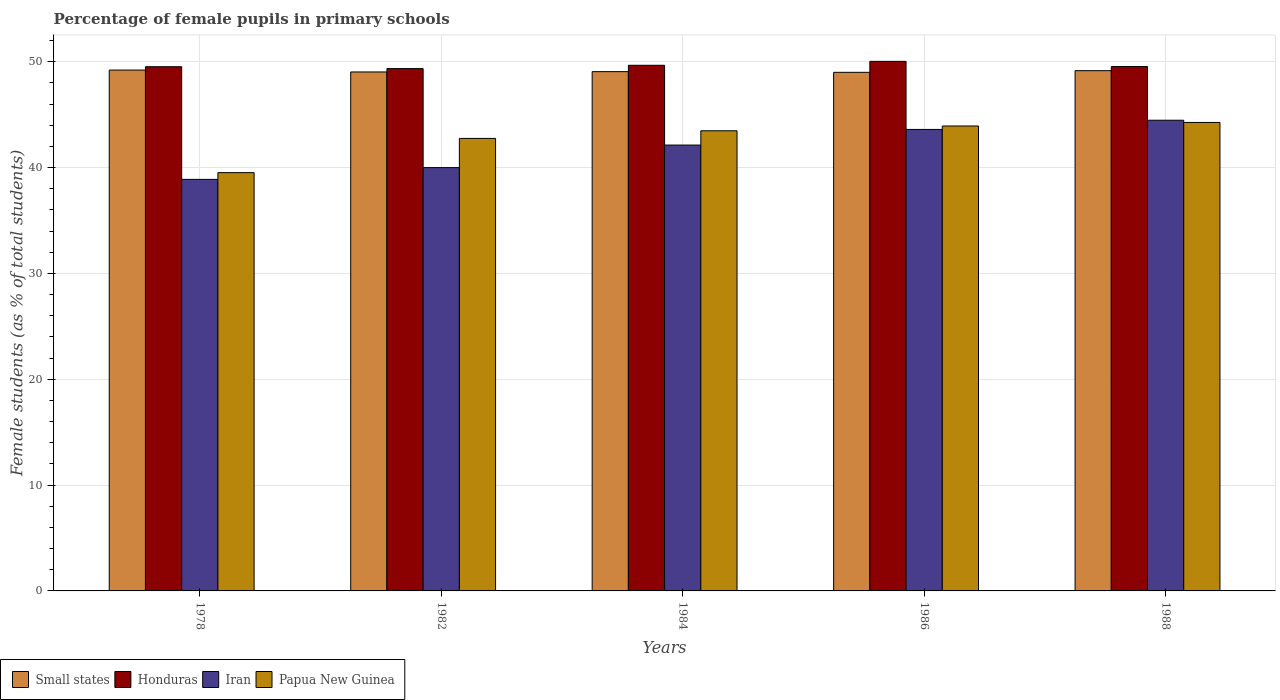How many different coloured bars are there?
Keep it short and to the point. 4. How many groups of bars are there?
Your response must be concise. 5. How many bars are there on the 4th tick from the left?
Your response must be concise. 4. In how many cases, is the number of bars for a given year not equal to the number of legend labels?
Make the answer very short. 0. What is the percentage of female pupils in primary schools in Iran in 1978?
Offer a very short reply. 38.89. Across all years, what is the maximum percentage of female pupils in primary schools in Honduras?
Offer a very short reply. 50.04. Across all years, what is the minimum percentage of female pupils in primary schools in Iran?
Keep it short and to the point. 38.89. In which year was the percentage of female pupils in primary schools in Iran maximum?
Ensure brevity in your answer.  1988. What is the total percentage of female pupils in primary schools in Papua New Guinea in the graph?
Your answer should be compact. 213.96. What is the difference between the percentage of female pupils in primary schools in Iran in 1982 and that in 1986?
Ensure brevity in your answer.  -3.61. What is the difference between the percentage of female pupils in primary schools in Papua New Guinea in 1988 and the percentage of female pupils in primary schools in Small states in 1982?
Ensure brevity in your answer.  -4.77. What is the average percentage of female pupils in primary schools in Iran per year?
Ensure brevity in your answer.  41.82. In the year 1984, what is the difference between the percentage of female pupils in primary schools in Papua New Guinea and percentage of female pupils in primary schools in Honduras?
Ensure brevity in your answer.  -6.19. In how many years, is the percentage of female pupils in primary schools in Honduras greater than 14 %?
Offer a very short reply. 5. What is the ratio of the percentage of female pupils in primary schools in Iran in 1978 to that in 1982?
Give a very brief answer. 0.97. Is the difference between the percentage of female pupils in primary schools in Papua New Guinea in 1984 and 1988 greater than the difference between the percentage of female pupils in primary schools in Honduras in 1984 and 1988?
Offer a very short reply. No. What is the difference between the highest and the second highest percentage of female pupils in primary schools in Honduras?
Offer a terse response. 0.37. What is the difference between the highest and the lowest percentage of female pupils in primary schools in Iran?
Your response must be concise. 5.59. In how many years, is the percentage of female pupils in primary schools in Honduras greater than the average percentage of female pupils in primary schools in Honduras taken over all years?
Provide a short and direct response. 2. Is it the case that in every year, the sum of the percentage of female pupils in primary schools in Honduras and percentage of female pupils in primary schools in Small states is greater than the sum of percentage of female pupils in primary schools in Iran and percentage of female pupils in primary schools in Papua New Guinea?
Your answer should be compact. No. What does the 4th bar from the left in 1982 represents?
Your response must be concise. Papua New Guinea. What does the 3rd bar from the right in 1982 represents?
Provide a short and direct response. Honduras. How many years are there in the graph?
Provide a short and direct response. 5. What is the difference between two consecutive major ticks on the Y-axis?
Offer a terse response. 10. Does the graph contain grids?
Make the answer very short. Yes. Where does the legend appear in the graph?
Your answer should be very brief. Bottom left. How many legend labels are there?
Offer a very short reply. 4. How are the legend labels stacked?
Your response must be concise. Horizontal. What is the title of the graph?
Keep it short and to the point. Percentage of female pupils in primary schools. What is the label or title of the X-axis?
Ensure brevity in your answer.  Years. What is the label or title of the Y-axis?
Your response must be concise. Female students (as % of total students). What is the Female students (as % of total students) of Small states in 1978?
Make the answer very short. 49.22. What is the Female students (as % of total students) in Honduras in 1978?
Make the answer very short. 49.53. What is the Female students (as % of total students) in Iran in 1978?
Your response must be concise. 38.89. What is the Female students (as % of total students) of Papua New Guinea in 1978?
Provide a succinct answer. 39.53. What is the Female students (as % of total students) in Small states in 1982?
Offer a very short reply. 49.04. What is the Female students (as % of total students) in Honduras in 1982?
Give a very brief answer. 49.36. What is the Female students (as % of total students) in Iran in 1982?
Your response must be concise. 40. What is the Female students (as % of total students) in Papua New Guinea in 1982?
Ensure brevity in your answer.  42.76. What is the Female students (as % of total students) of Small states in 1984?
Your answer should be compact. 49.07. What is the Female students (as % of total students) of Honduras in 1984?
Your answer should be compact. 49.67. What is the Female students (as % of total students) of Iran in 1984?
Your response must be concise. 42.13. What is the Female students (as % of total students) of Papua New Guinea in 1984?
Offer a terse response. 43.48. What is the Female students (as % of total students) of Small states in 1986?
Your response must be concise. 49. What is the Female students (as % of total students) in Honduras in 1986?
Give a very brief answer. 50.04. What is the Female students (as % of total students) in Iran in 1986?
Ensure brevity in your answer.  43.61. What is the Female students (as % of total students) in Papua New Guinea in 1986?
Your response must be concise. 43.93. What is the Female students (as % of total students) in Small states in 1988?
Your answer should be very brief. 49.16. What is the Female students (as % of total students) in Honduras in 1988?
Make the answer very short. 49.55. What is the Female students (as % of total students) of Iran in 1988?
Ensure brevity in your answer.  44.48. What is the Female students (as % of total students) of Papua New Guinea in 1988?
Your answer should be compact. 44.27. Across all years, what is the maximum Female students (as % of total students) of Small states?
Your response must be concise. 49.22. Across all years, what is the maximum Female students (as % of total students) of Honduras?
Give a very brief answer. 50.04. Across all years, what is the maximum Female students (as % of total students) in Iran?
Provide a succinct answer. 44.48. Across all years, what is the maximum Female students (as % of total students) in Papua New Guinea?
Give a very brief answer. 44.27. Across all years, what is the minimum Female students (as % of total students) of Small states?
Keep it short and to the point. 49. Across all years, what is the minimum Female students (as % of total students) of Honduras?
Offer a very short reply. 49.36. Across all years, what is the minimum Female students (as % of total students) in Iran?
Your response must be concise. 38.89. Across all years, what is the minimum Female students (as % of total students) of Papua New Guinea?
Make the answer very short. 39.53. What is the total Female students (as % of total students) of Small states in the graph?
Provide a short and direct response. 245.49. What is the total Female students (as % of total students) in Honduras in the graph?
Your answer should be very brief. 248.15. What is the total Female students (as % of total students) of Iran in the graph?
Your answer should be compact. 209.1. What is the total Female students (as % of total students) in Papua New Guinea in the graph?
Your answer should be very brief. 213.96. What is the difference between the Female students (as % of total students) of Small states in 1978 and that in 1982?
Your response must be concise. 0.18. What is the difference between the Female students (as % of total students) of Honduras in 1978 and that in 1982?
Offer a terse response. 0.18. What is the difference between the Female students (as % of total students) in Iran in 1978 and that in 1982?
Keep it short and to the point. -1.11. What is the difference between the Female students (as % of total students) in Papua New Guinea in 1978 and that in 1982?
Provide a short and direct response. -3.23. What is the difference between the Female students (as % of total students) of Small states in 1978 and that in 1984?
Offer a very short reply. 0.15. What is the difference between the Female students (as % of total students) of Honduras in 1978 and that in 1984?
Give a very brief answer. -0.14. What is the difference between the Female students (as % of total students) in Iran in 1978 and that in 1984?
Your answer should be very brief. -3.24. What is the difference between the Female students (as % of total students) of Papua New Guinea in 1978 and that in 1984?
Your answer should be very brief. -3.96. What is the difference between the Female students (as % of total students) in Small states in 1978 and that in 1986?
Provide a succinct answer. 0.21. What is the difference between the Female students (as % of total students) of Honduras in 1978 and that in 1986?
Offer a very short reply. -0.51. What is the difference between the Female students (as % of total students) of Iran in 1978 and that in 1986?
Make the answer very short. -4.72. What is the difference between the Female students (as % of total students) in Papua New Guinea in 1978 and that in 1986?
Keep it short and to the point. -4.41. What is the difference between the Female students (as % of total students) in Small states in 1978 and that in 1988?
Offer a very short reply. 0.06. What is the difference between the Female students (as % of total students) of Honduras in 1978 and that in 1988?
Offer a very short reply. -0.02. What is the difference between the Female students (as % of total students) of Iran in 1978 and that in 1988?
Provide a short and direct response. -5.59. What is the difference between the Female students (as % of total students) in Papua New Guinea in 1978 and that in 1988?
Give a very brief answer. -4.74. What is the difference between the Female students (as % of total students) in Small states in 1982 and that in 1984?
Offer a terse response. -0.03. What is the difference between the Female students (as % of total students) in Honduras in 1982 and that in 1984?
Provide a succinct answer. -0.31. What is the difference between the Female students (as % of total students) in Iran in 1982 and that in 1984?
Offer a terse response. -2.13. What is the difference between the Female students (as % of total students) in Papua New Guinea in 1982 and that in 1984?
Your response must be concise. -0.72. What is the difference between the Female students (as % of total students) in Small states in 1982 and that in 1986?
Make the answer very short. 0.04. What is the difference between the Female students (as % of total students) in Honduras in 1982 and that in 1986?
Offer a very short reply. -0.68. What is the difference between the Female students (as % of total students) in Iran in 1982 and that in 1986?
Your answer should be compact. -3.61. What is the difference between the Female students (as % of total students) in Papua New Guinea in 1982 and that in 1986?
Provide a short and direct response. -1.17. What is the difference between the Female students (as % of total students) in Small states in 1982 and that in 1988?
Your answer should be very brief. -0.12. What is the difference between the Female students (as % of total students) in Honduras in 1982 and that in 1988?
Ensure brevity in your answer.  -0.19. What is the difference between the Female students (as % of total students) of Iran in 1982 and that in 1988?
Your answer should be very brief. -4.48. What is the difference between the Female students (as % of total students) of Papua New Guinea in 1982 and that in 1988?
Make the answer very short. -1.51. What is the difference between the Female students (as % of total students) of Small states in 1984 and that in 1986?
Make the answer very short. 0.06. What is the difference between the Female students (as % of total students) in Honduras in 1984 and that in 1986?
Offer a very short reply. -0.37. What is the difference between the Female students (as % of total students) in Iran in 1984 and that in 1986?
Keep it short and to the point. -1.48. What is the difference between the Female students (as % of total students) of Papua New Guinea in 1984 and that in 1986?
Offer a very short reply. -0.45. What is the difference between the Female students (as % of total students) in Small states in 1984 and that in 1988?
Your answer should be very brief. -0.09. What is the difference between the Female students (as % of total students) of Honduras in 1984 and that in 1988?
Your answer should be very brief. 0.12. What is the difference between the Female students (as % of total students) of Iran in 1984 and that in 1988?
Your answer should be very brief. -2.35. What is the difference between the Female students (as % of total students) of Papua New Guinea in 1984 and that in 1988?
Your response must be concise. -0.79. What is the difference between the Female students (as % of total students) of Small states in 1986 and that in 1988?
Make the answer very short. -0.16. What is the difference between the Female students (as % of total students) in Honduras in 1986 and that in 1988?
Ensure brevity in your answer.  0.49. What is the difference between the Female students (as % of total students) in Iran in 1986 and that in 1988?
Provide a short and direct response. -0.87. What is the difference between the Female students (as % of total students) of Papua New Guinea in 1986 and that in 1988?
Your answer should be very brief. -0.34. What is the difference between the Female students (as % of total students) of Small states in 1978 and the Female students (as % of total students) of Honduras in 1982?
Give a very brief answer. -0.14. What is the difference between the Female students (as % of total students) of Small states in 1978 and the Female students (as % of total students) of Iran in 1982?
Keep it short and to the point. 9.22. What is the difference between the Female students (as % of total students) in Small states in 1978 and the Female students (as % of total students) in Papua New Guinea in 1982?
Provide a succinct answer. 6.46. What is the difference between the Female students (as % of total students) of Honduras in 1978 and the Female students (as % of total students) of Iran in 1982?
Your response must be concise. 9.53. What is the difference between the Female students (as % of total students) in Honduras in 1978 and the Female students (as % of total students) in Papua New Guinea in 1982?
Your answer should be compact. 6.77. What is the difference between the Female students (as % of total students) in Iran in 1978 and the Female students (as % of total students) in Papua New Guinea in 1982?
Ensure brevity in your answer.  -3.87. What is the difference between the Female students (as % of total students) in Small states in 1978 and the Female students (as % of total students) in Honduras in 1984?
Ensure brevity in your answer.  -0.45. What is the difference between the Female students (as % of total students) of Small states in 1978 and the Female students (as % of total students) of Iran in 1984?
Your response must be concise. 7.09. What is the difference between the Female students (as % of total students) in Small states in 1978 and the Female students (as % of total students) in Papua New Guinea in 1984?
Provide a succinct answer. 5.74. What is the difference between the Female students (as % of total students) in Honduras in 1978 and the Female students (as % of total students) in Iran in 1984?
Provide a short and direct response. 7.4. What is the difference between the Female students (as % of total students) in Honduras in 1978 and the Female students (as % of total students) in Papua New Guinea in 1984?
Keep it short and to the point. 6.05. What is the difference between the Female students (as % of total students) of Iran in 1978 and the Female students (as % of total students) of Papua New Guinea in 1984?
Offer a terse response. -4.59. What is the difference between the Female students (as % of total students) in Small states in 1978 and the Female students (as % of total students) in Honduras in 1986?
Ensure brevity in your answer.  -0.82. What is the difference between the Female students (as % of total students) of Small states in 1978 and the Female students (as % of total students) of Iran in 1986?
Provide a succinct answer. 5.61. What is the difference between the Female students (as % of total students) in Small states in 1978 and the Female students (as % of total students) in Papua New Guinea in 1986?
Make the answer very short. 5.29. What is the difference between the Female students (as % of total students) of Honduras in 1978 and the Female students (as % of total students) of Iran in 1986?
Your response must be concise. 5.93. What is the difference between the Female students (as % of total students) of Honduras in 1978 and the Female students (as % of total students) of Papua New Guinea in 1986?
Your answer should be very brief. 5.6. What is the difference between the Female students (as % of total students) in Iran in 1978 and the Female students (as % of total students) in Papua New Guinea in 1986?
Provide a succinct answer. -5.04. What is the difference between the Female students (as % of total students) in Small states in 1978 and the Female students (as % of total students) in Honduras in 1988?
Provide a short and direct response. -0.33. What is the difference between the Female students (as % of total students) in Small states in 1978 and the Female students (as % of total students) in Iran in 1988?
Provide a short and direct response. 4.74. What is the difference between the Female students (as % of total students) in Small states in 1978 and the Female students (as % of total students) in Papua New Guinea in 1988?
Offer a very short reply. 4.95. What is the difference between the Female students (as % of total students) of Honduras in 1978 and the Female students (as % of total students) of Iran in 1988?
Provide a short and direct response. 5.06. What is the difference between the Female students (as % of total students) of Honduras in 1978 and the Female students (as % of total students) of Papua New Guinea in 1988?
Your response must be concise. 5.27. What is the difference between the Female students (as % of total students) of Iran in 1978 and the Female students (as % of total students) of Papua New Guinea in 1988?
Give a very brief answer. -5.38. What is the difference between the Female students (as % of total students) of Small states in 1982 and the Female students (as % of total students) of Honduras in 1984?
Provide a succinct answer. -0.63. What is the difference between the Female students (as % of total students) of Small states in 1982 and the Female students (as % of total students) of Iran in 1984?
Give a very brief answer. 6.91. What is the difference between the Female students (as % of total students) in Small states in 1982 and the Female students (as % of total students) in Papua New Guinea in 1984?
Ensure brevity in your answer.  5.56. What is the difference between the Female students (as % of total students) in Honduras in 1982 and the Female students (as % of total students) in Iran in 1984?
Provide a short and direct response. 7.23. What is the difference between the Female students (as % of total students) in Honduras in 1982 and the Female students (as % of total students) in Papua New Guinea in 1984?
Your answer should be very brief. 5.87. What is the difference between the Female students (as % of total students) of Iran in 1982 and the Female students (as % of total students) of Papua New Guinea in 1984?
Offer a terse response. -3.48. What is the difference between the Female students (as % of total students) of Small states in 1982 and the Female students (as % of total students) of Honduras in 1986?
Your response must be concise. -1. What is the difference between the Female students (as % of total students) of Small states in 1982 and the Female students (as % of total students) of Iran in 1986?
Make the answer very short. 5.43. What is the difference between the Female students (as % of total students) in Small states in 1982 and the Female students (as % of total students) in Papua New Guinea in 1986?
Provide a succinct answer. 5.11. What is the difference between the Female students (as % of total students) in Honduras in 1982 and the Female students (as % of total students) in Iran in 1986?
Make the answer very short. 5.75. What is the difference between the Female students (as % of total students) in Honduras in 1982 and the Female students (as % of total students) in Papua New Guinea in 1986?
Keep it short and to the point. 5.42. What is the difference between the Female students (as % of total students) of Iran in 1982 and the Female students (as % of total students) of Papua New Guinea in 1986?
Keep it short and to the point. -3.93. What is the difference between the Female students (as % of total students) of Small states in 1982 and the Female students (as % of total students) of Honduras in 1988?
Offer a very short reply. -0.51. What is the difference between the Female students (as % of total students) of Small states in 1982 and the Female students (as % of total students) of Iran in 1988?
Make the answer very short. 4.56. What is the difference between the Female students (as % of total students) in Small states in 1982 and the Female students (as % of total students) in Papua New Guinea in 1988?
Your answer should be very brief. 4.77. What is the difference between the Female students (as % of total students) of Honduras in 1982 and the Female students (as % of total students) of Iran in 1988?
Ensure brevity in your answer.  4.88. What is the difference between the Female students (as % of total students) of Honduras in 1982 and the Female students (as % of total students) of Papua New Guinea in 1988?
Offer a very short reply. 5.09. What is the difference between the Female students (as % of total students) of Iran in 1982 and the Female students (as % of total students) of Papua New Guinea in 1988?
Provide a short and direct response. -4.27. What is the difference between the Female students (as % of total students) in Small states in 1984 and the Female students (as % of total students) in Honduras in 1986?
Keep it short and to the point. -0.97. What is the difference between the Female students (as % of total students) of Small states in 1984 and the Female students (as % of total students) of Iran in 1986?
Give a very brief answer. 5.46. What is the difference between the Female students (as % of total students) in Small states in 1984 and the Female students (as % of total students) in Papua New Guinea in 1986?
Your response must be concise. 5.14. What is the difference between the Female students (as % of total students) of Honduras in 1984 and the Female students (as % of total students) of Iran in 1986?
Make the answer very short. 6.06. What is the difference between the Female students (as % of total students) of Honduras in 1984 and the Female students (as % of total students) of Papua New Guinea in 1986?
Keep it short and to the point. 5.74. What is the difference between the Female students (as % of total students) in Iran in 1984 and the Female students (as % of total students) in Papua New Guinea in 1986?
Provide a short and direct response. -1.8. What is the difference between the Female students (as % of total students) in Small states in 1984 and the Female students (as % of total students) in Honduras in 1988?
Your response must be concise. -0.48. What is the difference between the Female students (as % of total students) in Small states in 1984 and the Female students (as % of total students) in Iran in 1988?
Your response must be concise. 4.59. What is the difference between the Female students (as % of total students) of Small states in 1984 and the Female students (as % of total students) of Papua New Guinea in 1988?
Provide a short and direct response. 4.8. What is the difference between the Female students (as % of total students) of Honduras in 1984 and the Female students (as % of total students) of Iran in 1988?
Your answer should be very brief. 5.19. What is the difference between the Female students (as % of total students) in Honduras in 1984 and the Female students (as % of total students) in Papua New Guinea in 1988?
Ensure brevity in your answer.  5.4. What is the difference between the Female students (as % of total students) of Iran in 1984 and the Female students (as % of total students) of Papua New Guinea in 1988?
Your answer should be compact. -2.14. What is the difference between the Female students (as % of total students) of Small states in 1986 and the Female students (as % of total students) of Honduras in 1988?
Provide a short and direct response. -0.55. What is the difference between the Female students (as % of total students) of Small states in 1986 and the Female students (as % of total students) of Iran in 1988?
Offer a terse response. 4.53. What is the difference between the Female students (as % of total students) in Small states in 1986 and the Female students (as % of total students) in Papua New Guinea in 1988?
Offer a terse response. 4.74. What is the difference between the Female students (as % of total students) of Honduras in 1986 and the Female students (as % of total students) of Iran in 1988?
Provide a short and direct response. 5.56. What is the difference between the Female students (as % of total students) in Honduras in 1986 and the Female students (as % of total students) in Papua New Guinea in 1988?
Your answer should be very brief. 5.77. What is the difference between the Female students (as % of total students) in Iran in 1986 and the Female students (as % of total students) in Papua New Guinea in 1988?
Your answer should be compact. -0.66. What is the average Female students (as % of total students) in Small states per year?
Give a very brief answer. 49.1. What is the average Female students (as % of total students) in Honduras per year?
Keep it short and to the point. 49.63. What is the average Female students (as % of total students) of Iran per year?
Make the answer very short. 41.82. What is the average Female students (as % of total students) in Papua New Guinea per year?
Provide a succinct answer. 42.79. In the year 1978, what is the difference between the Female students (as % of total students) in Small states and Female students (as % of total students) in Honduras?
Ensure brevity in your answer.  -0.31. In the year 1978, what is the difference between the Female students (as % of total students) in Small states and Female students (as % of total students) in Iran?
Make the answer very short. 10.33. In the year 1978, what is the difference between the Female students (as % of total students) of Small states and Female students (as % of total students) of Papua New Guinea?
Make the answer very short. 9.69. In the year 1978, what is the difference between the Female students (as % of total students) in Honduras and Female students (as % of total students) in Iran?
Provide a succinct answer. 10.64. In the year 1978, what is the difference between the Female students (as % of total students) in Honduras and Female students (as % of total students) in Papua New Guinea?
Make the answer very short. 10.01. In the year 1978, what is the difference between the Female students (as % of total students) of Iran and Female students (as % of total students) of Papua New Guinea?
Keep it short and to the point. -0.64. In the year 1982, what is the difference between the Female students (as % of total students) of Small states and Female students (as % of total students) of Honduras?
Your answer should be very brief. -0.32. In the year 1982, what is the difference between the Female students (as % of total students) of Small states and Female students (as % of total students) of Iran?
Make the answer very short. 9.04. In the year 1982, what is the difference between the Female students (as % of total students) of Small states and Female students (as % of total students) of Papua New Guinea?
Provide a succinct answer. 6.28. In the year 1982, what is the difference between the Female students (as % of total students) in Honduras and Female students (as % of total students) in Iran?
Give a very brief answer. 9.36. In the year 1982, what is the difference between the Female students (as % of total students) in Honduras and Female students (as % of total students) in Papua New Guinea?
Keep it short and to the point. 6.6. In the year 1982, what is the difference between the Female students (as % of total students) of Iran and Female students (as % of total students) of Papua New Guinea?
Keep it short and to the point. -2.76. In the year 1984, what is the difference between the Female students (as % of total students) of Small states and Female students (as % of total students) of Honduras?
Give a very brief answer. -0.6. In the year 1984, what is the difference between the Female students (as % of total students) in Small states and Female students (as % of total students) in Iran?
Offer a terse response. 6.94. In the year 1984, what is the difference between the Female students (as % of total students) of Small states and Female students (as % of total students) of Papua New Guinea?
Ensure brevity in your answer.  5.59. In the year 1984, what is the difference between the Female students (as % of total students) of Honduras and Female students (as % of total students) of Iran?
Provide a succinct answer. 7.54. In the year 1984, what is the difference between the Female students (as % of total students) in Honduras and Female students (as % of total students) in Papua New Guinea?
Ensure brevity in your answer.  6.19. In the year 1984, what is the difference between the Female students (as % of total students) in Iran and Female students (as % of total students) in Papua New Guinea?
Provide a succinct answer. -1.35. In the year 1986, what is the difference between the Female students (as % of total students) of Small states and Female students (as % of total students) of Honduras?
Your response must be concise. -1.04. In the year 1986, what is the difference between the Female students (as % of total students) of Small states and Female students (as % of total students) of Iran?
Your answer should be compact. 5.4. In the year 1986, what is the difference between the Female students (as % of total students) of Small states and Female students (as % of total students) of Papua New Guinea?
Your response must be concise. 5.07. In the year 1986, what is the difference between the Female students (as % of total students) of Honduras and Female students (as % of total students) of Iran?
Provide a succinct answer. 6.43. In the year 1986, what is the difference between the Female students (as % of total students) in Honduras and Female students (as % of total students) in Papua New Guinea?
Keep it short and to the point. 6.11. In the year 1986, what is the difference between the Female students (as % of total students) of Iran and Female students (as % of total students) of Papua New Guinea?
Give a very brief answer. -0.32. In the year 1988, what is the difference between the Female students (as % of total students) in Small states and Female students (as % of total students) in Honduras?
Provide a short and direct response. -0.39. In the year 1988, what is the difference between the Female students (as % of total students) in Small states and Female students (as % of total students) in Iran?
Offer a very short reply. 4.68. In the year 1988, what is the difference between the Female students (as % of total students) of Small states and Female students (as % of total students) of Papua New Guinea?
Provide a short and direct response. 4.89. In the year 1988, what is the difference between the Female students (as % of total students) of Honduras and Female students (as % of total students) of Iran?
Give a very brief answer. 5.07. In the year 1988, what is the difference between the Female students (as % of total students) in Honduras and Female students (as % of total students) in Papua New Guinea?
Make the answer very short. 5.28. In the year 1988, what is the difference between the Female students (as % of total students) in Iran and Female students (as % of total students) in Papua New Guinea?
Offer a very short reply. 0.21. What is the ratio of the Female students (as % of total students) of Small states in 1978 to that in 1982?
Offer a very short reply. 1. What is the ratio of the Female students (as % of total students) of Honduras in 1978 to that in 1982?
Keep it short and to the point. 1. What is the ratio of the Female students (as % of total students) of Iran in 1978 to that in 1982?
Give a very brief answer. 0.97. What is the ratio of the Female students (as % of total students) of Papua New Guinea in 1978 to that in 1982?
Your answer should be very brief. 0.92. What is the ratio of the Female students (as % of total students) of Small states in 1978 to that in 1984?
Provide a succinct answer. 1. What is the ratio of the Female students (as % of total students) of Honduras in 1978 to that in 1984?
Your response must be concise. 1. What is the ratio of the Female students (as % of total students) in Iran in 1978 to that in 1984?
Make the answer very short. 0.92. What is the ratio of the Female students (as % of total students) in Papua New Guinea in 1978 to that in 1984?
Provide a short and direct response. 0.91. What is the ratio of the Female students (as % of total students) in Small states in 1978 to that in 1986?
Ensure brevity in your answer.  1. What is the ratio of the Female students (as % of total students) of Honduras in 1978 to that in 1986?
Keep it short and to the point. 0.99. What is the ratio of the Female students (as % of total students) of Iran in 1978 to that in 1986?
Your answer should be very brief. 0.89. What is the ratio of the Female students (as % of total students) in Papua New Guinea in 1978 to that in 1986?
Offer a very short reply. 0.9. What is the ratio of the Female students (as % of total students) of Iran in 1978 to that in 1988?
Provide a short and direct response. 0.87. What is the ratio of the Female students (as % of total students) in Papua New Guinea in 1978 to that in 1988?
Offer a very short reply. 0.89. What is the ratio of the Female students (as % of total students) of Small states in 1982 to that in 1984?
Give a very brief answer. 1. What is the ratio of the Female students (as % of total students) of Honduras in 1982 to that in 1984?
Provide a succinct answer. 0.99. What is the ratio of the Female students (as % of total students) of Iran in 1982 to that in 1984?
Ensure brevity in your answer.  0.95. What is the ratio of the Female students (as % of total students) of Papua New Guinea in 1982 to that in 1984?
Offer a terse response. 0.98. What is the ratio of the Female students (as % of total students) in Honduras in 1982 to that in 1986?
Keep it short and to the point. 0.99. What is the ratio of the Female students (as % of total students) of Iran in 1982 to that in 1986?
Make the answer very short. 0.92. What is the ratio of the Female students (as % of total students) in Papua New Guinea in 1982 to that in 1986?
Your response must be concise. 0.97. What is the ratio of the Female students (as % of total students) in Small states in 1982 to that in 1988?
Your response must be concise. 1. What is the ratio of the Female students (as % of total students) of Iran in 1982 to that in 1988?
Make the answer very short. 0.9. What is the ratio of the Female students (as % of total students) of Papua New Guinea in 1982 to that in 1988?
Provide a succinct answer. 0.97. What is the ratio of the Female students (as % of total students) in Iran in 1984 to that in 1986?
Keep it short and to the point. 0.97. What is the ratio of the Female students (as % of total students) in Papua New Guinea in 1984 to that in 1986?
Provide a short and direct response. 0.99. What is the ratio of the Female students (as % of total students) in Iran in 1984 to that in 1988?
Your answer should be very brief. 0.95. What is the ratio of the Female students (as % of total students) of Papua New Guinea in 1984 to that in 1988?
Your answer should be compact. 0.98. What is the ratio of the Female students (as % of total students) in Honduras in 1986 to that in 1988?
Make the answer very short. 1.01. What is the ratio of the Female students (as % of total students) in Iran in 1986 to that in 1988?
Offer a very short reply. 0.98. What is the ratio of the Female students (as % of total students) in Papua New Guinea in 1986 to that in 1988?
Make the answer very short. 0.99. What is the difference between the highest and the second highest Female students (as % of total students) in Small states?
Your answer should be compact. 0.06. What is the difference between the highest and the second highest Female students (as % of total students) of Honduras?
Give a very brief answer. 0.37. What is the difference between the highest and the second highest Female students (as % of total students) of Iran?
Your answer should be compact. 0.87. What is the difference between the highest and the second highest Female students (as % of total students) of Papua New Guinea?
Give a very brief answer. 0.34. What is the difference between the highest and the lowest Female students (as % of total students) in Small states?
Make the answer very short. 0.21. What is the difference between the highest and the lowest Female students (as % of total students) in Honduras?
Offer a terse response. 0.68. What is the difference between the highest and the lowest Female students (as % of total students) of Iran?
Make the answer very short. 5.59. What is the difference between the highest and the lowest Female students (as % of total students) of Papua New Guinea?
Make the answer very short. 4.74. 